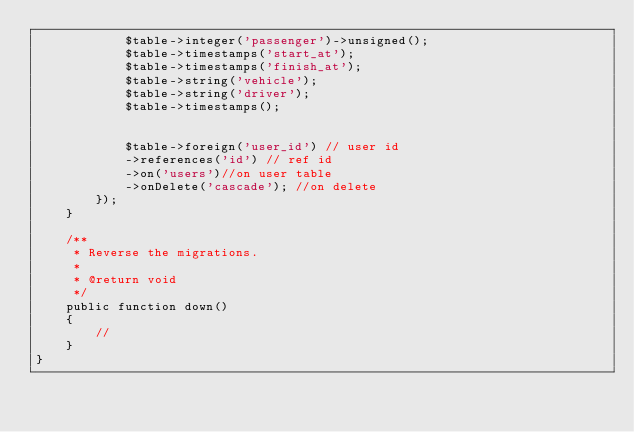Convert code to text. <code><loc_0><loc_0><loc_500><loc_500><_PHP_>            $table->integer('passenger')->unsigned();
            $table->timestamps('start_at');
            $table->timestamps('finish_at');
            $table->string('vehicle');
            $table->string('driver');
            $table->timestamps();


            $table->foreign('user_id') // user id
            ->references('id') // ref id
            ->on('users')//on user table
            ->onDelete('cascade'); //on delete
        });
    }

    /**
     * Reverse the migrations.
     *
     * @return void
     */
    public function down()
    {
        //
    }
}
</code> 